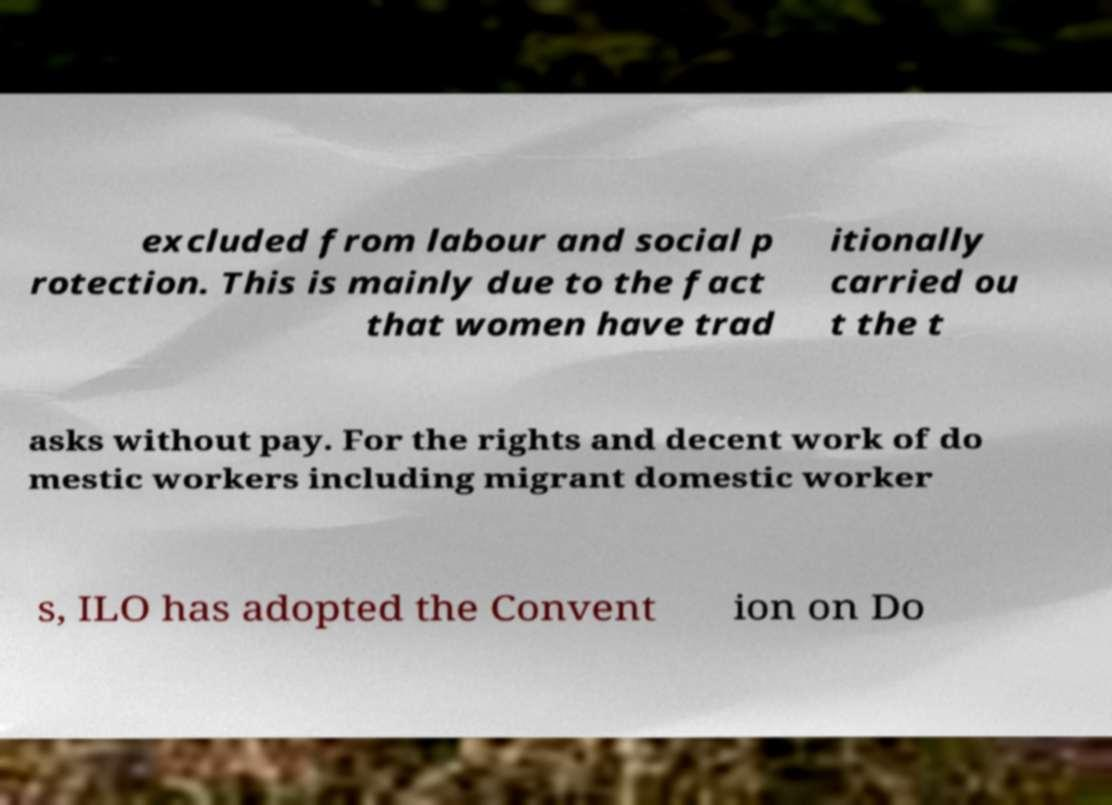Can you accurately transcribe the text from the provided image for me? excluded from labour and social p rotection. This is mainly due to the fact that women have trad itionally carried ou t the t asks without pay. For the rights and decent work of do mestic workers including migrant domestic worker s, ILO has adopted the Convent ion on Do 